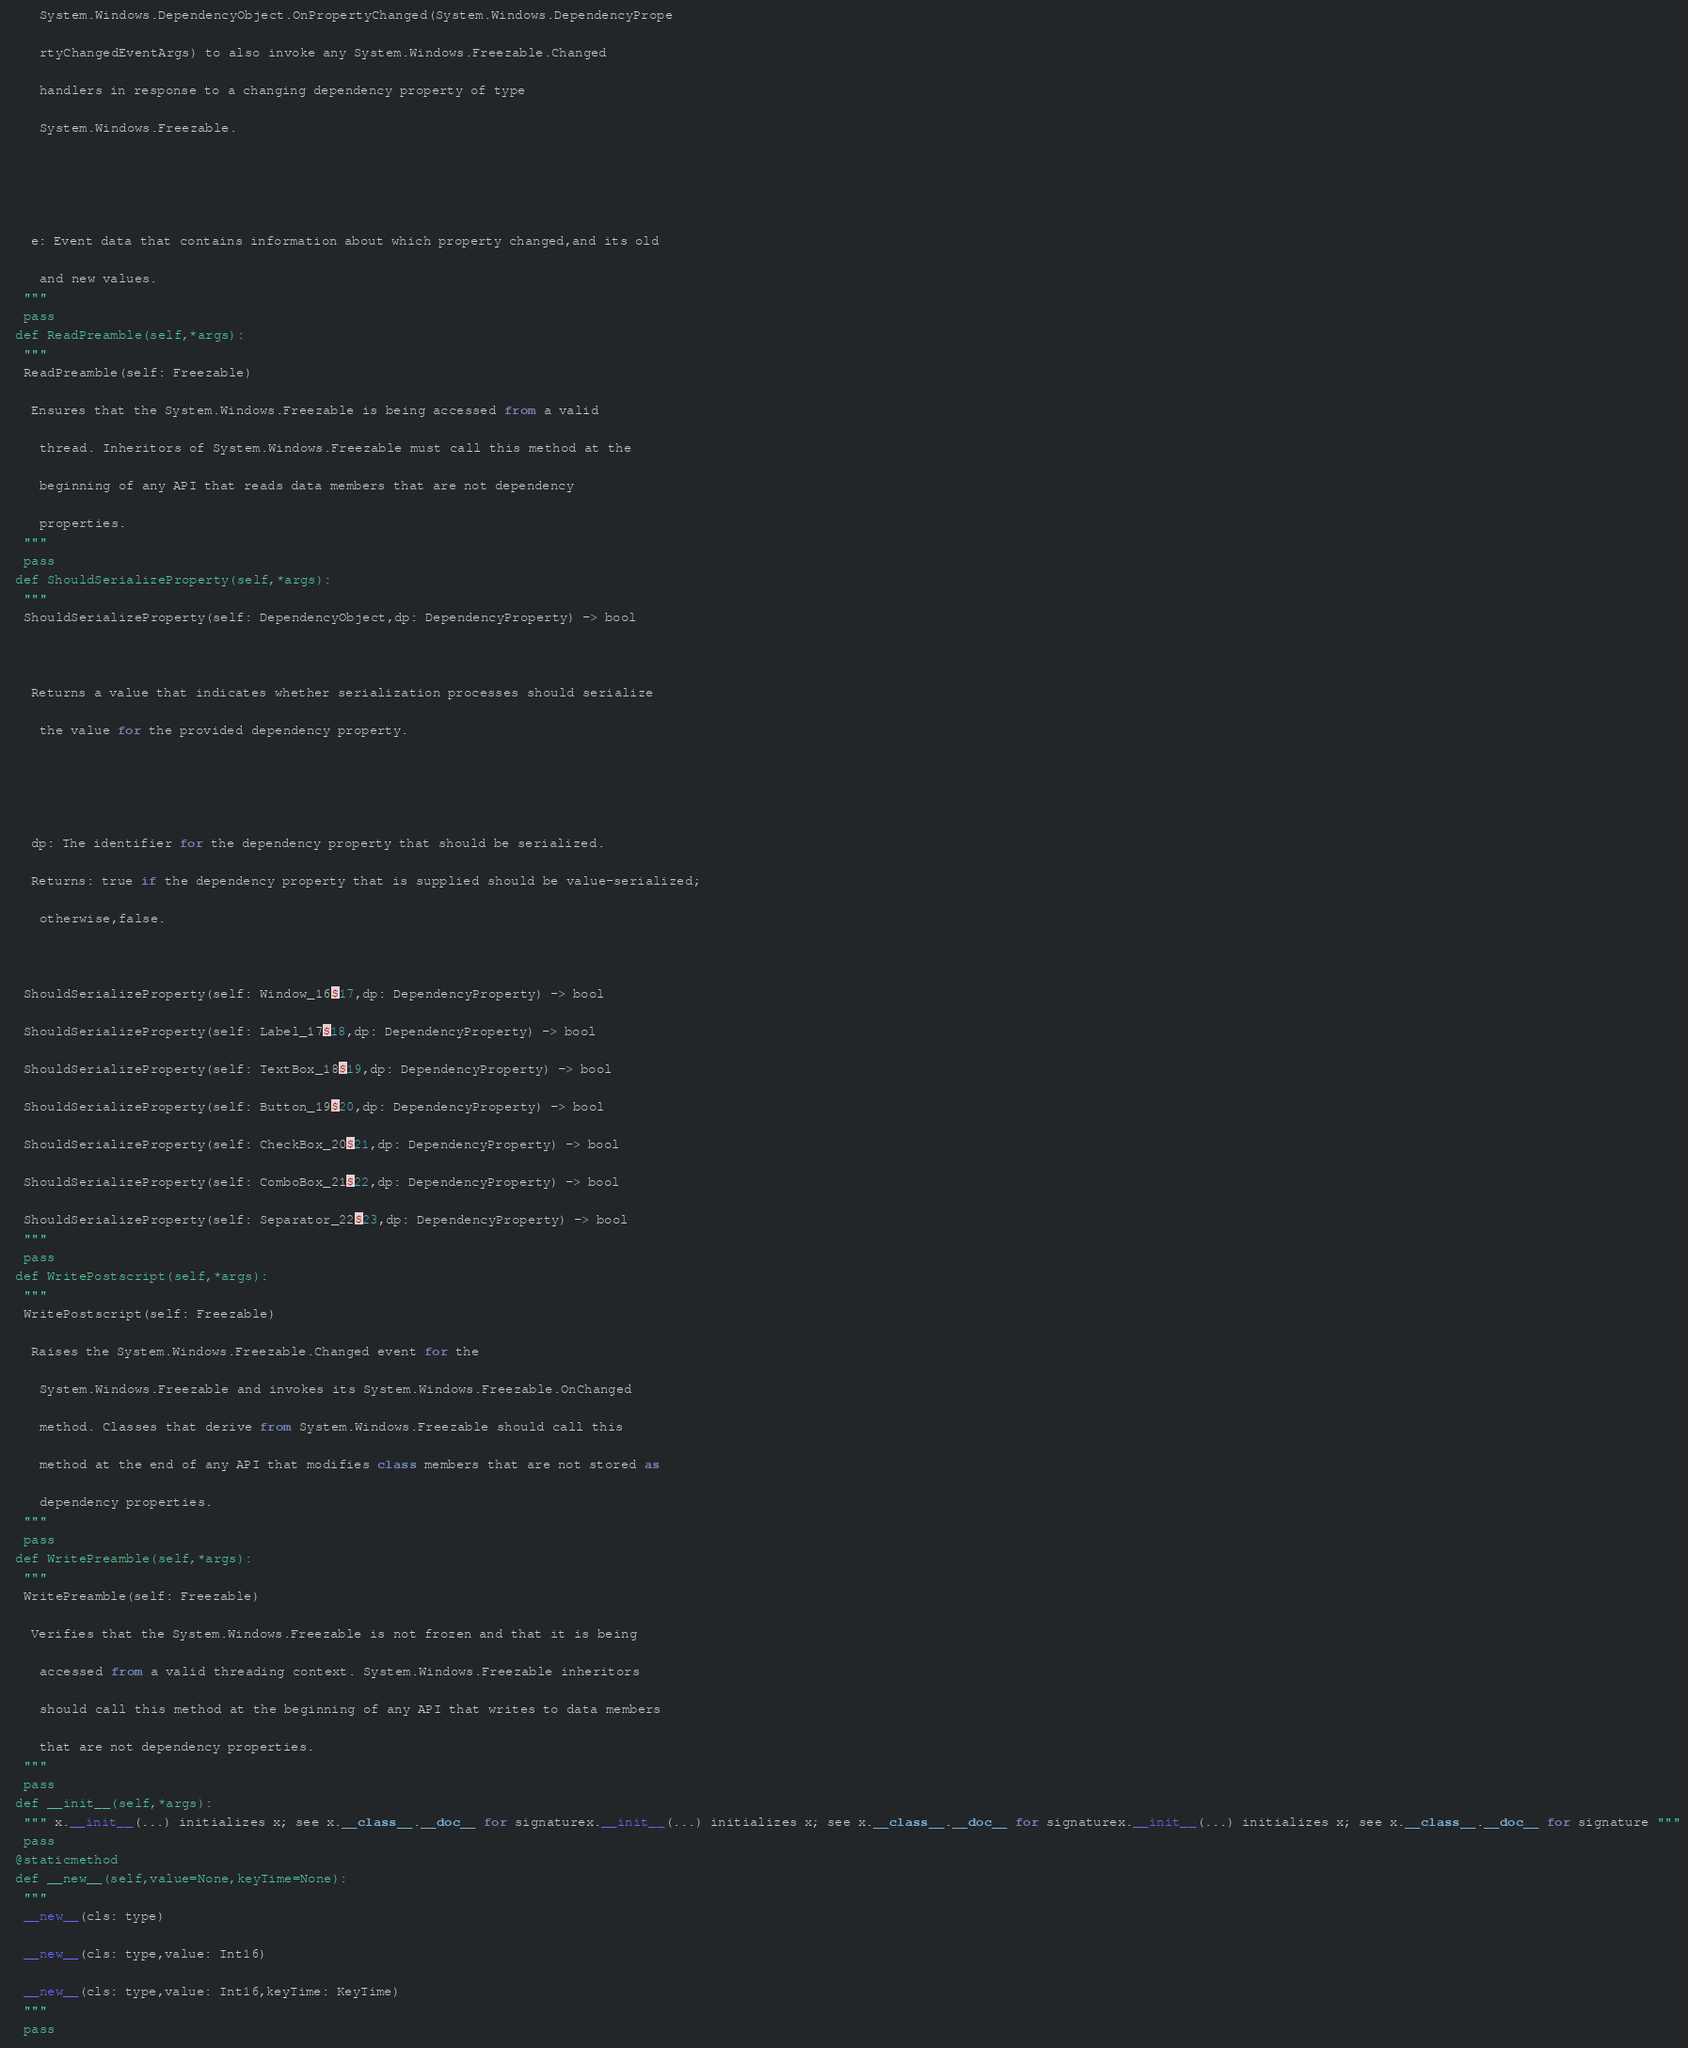Convert code to text. <code><loc_0><loc_0><loc_500><loc_500><_Python_>    System.Windows.DependencyObject.OnPropertyChanged(System.Windows.DependencyPrope
    rtyChangedEventArgs) to also invoke any System.Windows.Freezable.Changed 
    handlers in response to a changing dependency property of type 
    System.Windows.Freezable.
  
  
   e: Event data that contains information about which property changed,and its old 
    and new values.
  """
  pass
 def ReadPreamble(self,*args):
  """
  ReadPreamble(self: Freezable)
   Ensures that the System.Windows.Freezable is being accessed from a valid 
    thread. Inheritors of System.Windows.Freezable must call this method at the 
    beginning of any API that reads data members that are not dependency 
    properties.
  """
  pass
 def ShouldSerializeProperty(self,*args):
  """
  ShouldSerializeProperty(self: DependencyObject,dp: DependencyProperty) -> bool
  
   Returns a value that indicates whether serialization processes should serialize 
    the value for the provided dependency property.
  
  
   dp: The identifier for the dependency property that should be serialized.
   Returns: true if the dependency property that is supplied should be value-serialized; 
    otherwise,false.
  
  ShouldSerializeProperty(self: Window_16$17,dp: DependencyProperty) -> bool
  ShouldSerializeProperty(self: Label_17$18,dp: DependencyProperty) -> bool
  ShouldSerializeProperty(self: TextBox_18$19,dp: DependencyProperty) -> bool
  ShouldSerializeProperty(self: Button_19$20,dp: DependencyProperty) -> bool
  ShouldSerializeProperty(self: CheckBox_20$21,dp: DependencyProperty) -> bool
  ShouldSerializeProperty(self: ComboBox_21$22,dp: DependencyProperty) -> bool
  ShouldSerializeProperty(self: Separator_22$23,dp: DependencyProperty) -> bool
  """
  pass
 def WritePostscript(self,*args):
  """
  WritePostscript(self: Freezable)
   Raises the System.Windows.Freezable.Changed event for the 
    System.Windows.Freezable and invokes its System.Windows.Freezable.OnChanged 
    method. Classes that derive from System.Windows.Freezable should call this 
    method at the end of any API that modifies class members that are not stored as 
    dependency properties.
  """
  pass
 def WritePreamble(self,*args):
  """
  WritePreamble(self: Freezable)
   Verifies that the System.Windows.Freezable is not frozen and that it is being 
    accessed from a valid threading context. System.Windows.Freezable inheritors 
    should call this method at the beginning of any API that writes to data members 
    that are not dependency properties.
  """
  pass
 def __init__(self,*args):
  """ x.__init__(...) initializes x; see x.__class__.__doc__ for signaturex.__init__(...) initializes x; see x.__class__.__doc__ for signaturex.__init__(...) initializes x; see x.__class__.__doc__ for signature """
  pass
 @staticmethod
 def __new__(self,value=None,keyTime=None):
  """
  __new__(cls: type)
  __new__(cls: type,value: Int16)
  __new__(cls: type,value: Int16,keyTime: KeyTime)
  """
  pass
</code> 